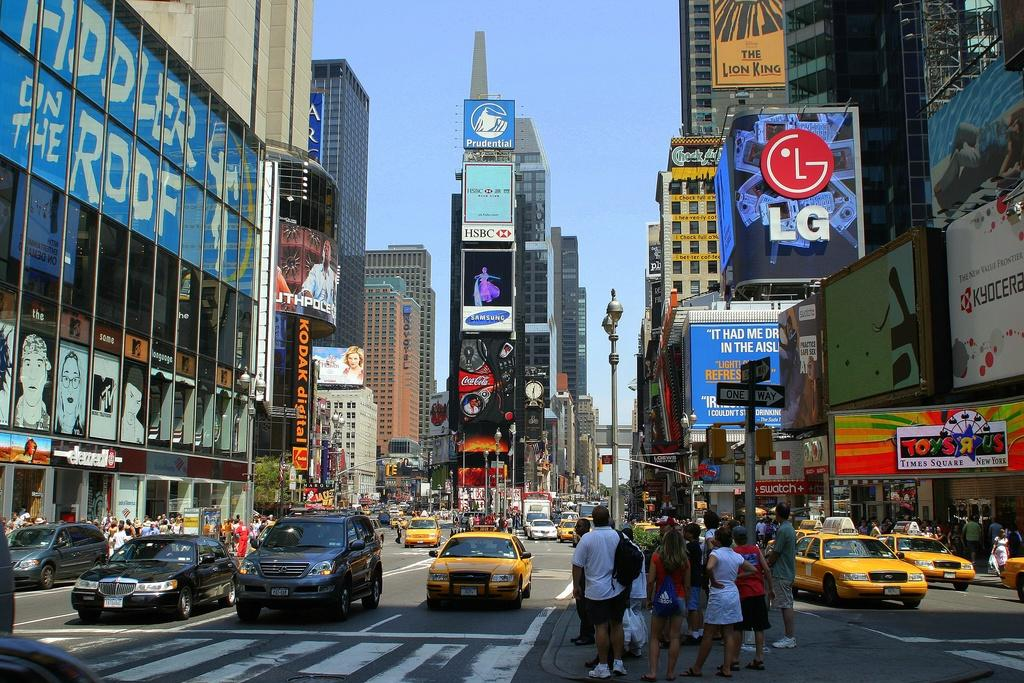<image>
Create a compact narrative representing the image presented. A busy city street has pedestrians waiting to cross under a sign that says Fiddler on the Roof. 